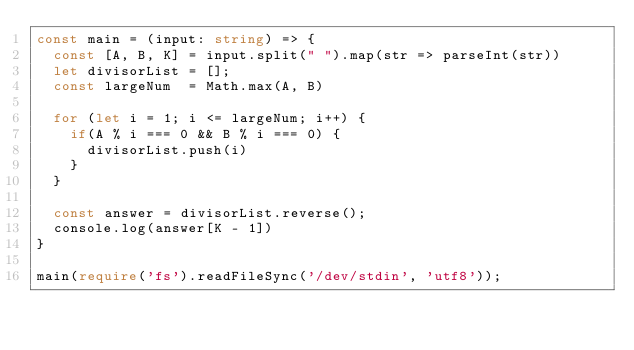<code> <loc_0><loc_0><loc_500><loc_500><_TypeScript_>const main = (input: string) => {
  const [A, B, K] = input.split(" ").map(str => parseInt(str))
  let divisorList = [];
  const largeNum  = Math.max(A, B)

  for (let i = 1; i <= largeNum; i++) {
    if(A % i === 0 && B % i === 0) {
      divisorList.push(i)
    }
  }

  const answer = divisorList.reverse();
  console.log(answer[K - 1])
}

main(require('fs').readFileSync('/dev/stdin', 'utf8'));
</code> 